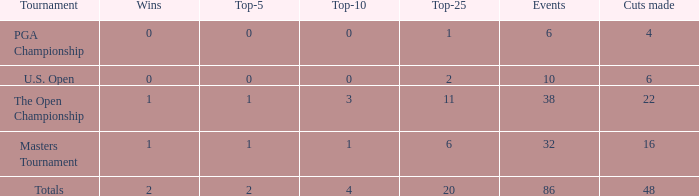Tell me the total number of events for tournament of masters tournament and top 25 less than 6 0.0. 